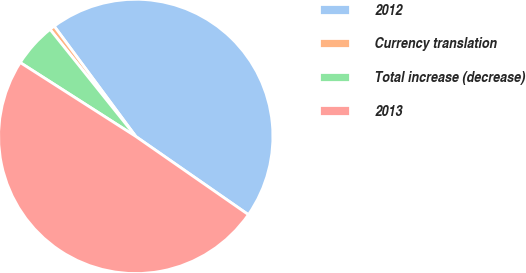Convert chart to OTSL. <chart><loc_0><loc_0><loc_500><loc_500><pie_chart><fcel>2012<fcel>Currency translation<fcel>Total increase (decrease)<fcel>2013<nl><fcel>44.8%<fcel>0.61%<fcel>5.2%<fcel>49.39%<nl></chart> 